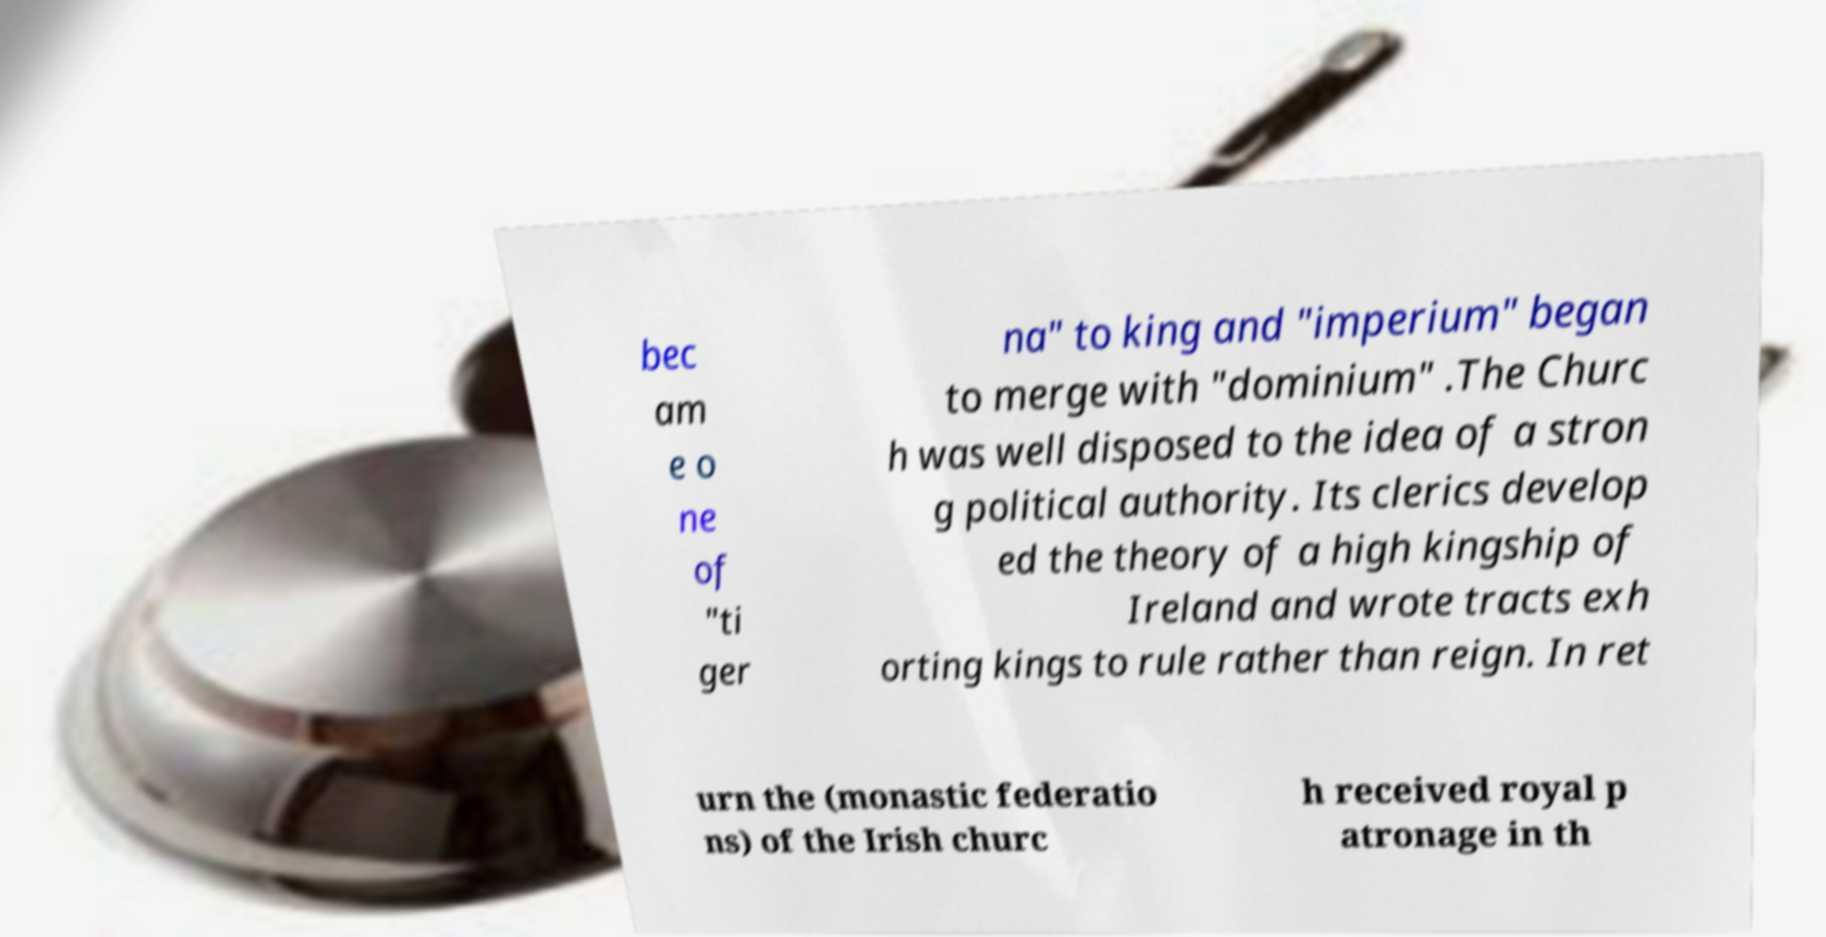Please read and relay the text visible in this image. What does it say? bec am e o ne of "ti ger na" to king and "imperium" began to merge with "dominium" .The Churc h was well disposed to the idea of a stron g political authority. Its clerics develop ed the theory of a high kingship of Ireland and wrote tracts exh orting kings to rule rather than reign. In ret urn the (monastic federatio ns) of the Irish churc h received royal p atronage in th 